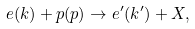<formula> <loc_0><loc_0><loc_500><loc_500>e ( k ) + p ( p ) \rightarrow e ^ { \prime } ( k ^ { \prime } ) + X ,</formula> 